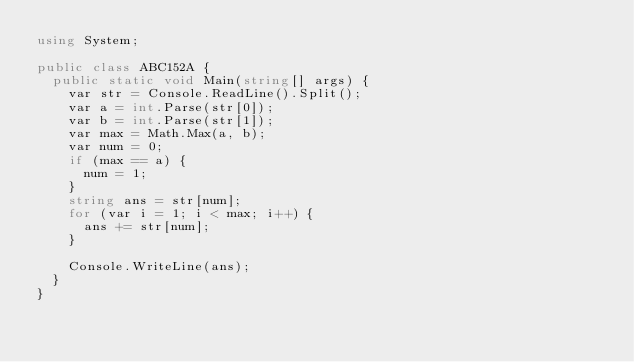Convert code to text. <code><loc_0><loc_0><loc_500><loc_500><_C#_>using System;

public class ABC152A {
  public static void Main(string[] args) {
    var str = Console.ReadLine().Split();
    var a = int.Parse(str[0]);
    var b = int.Parse(str[1]);
    var max = Math.Max(a, b);
    var num = 0;
    if (max == a) {
      num = 1;
    }
    string ans = str[num];
    for (var i = 1; i < max; i++) {
      ans += str[num];
    }
    
    Console.WriteLine(ans);
  }
}</code> 